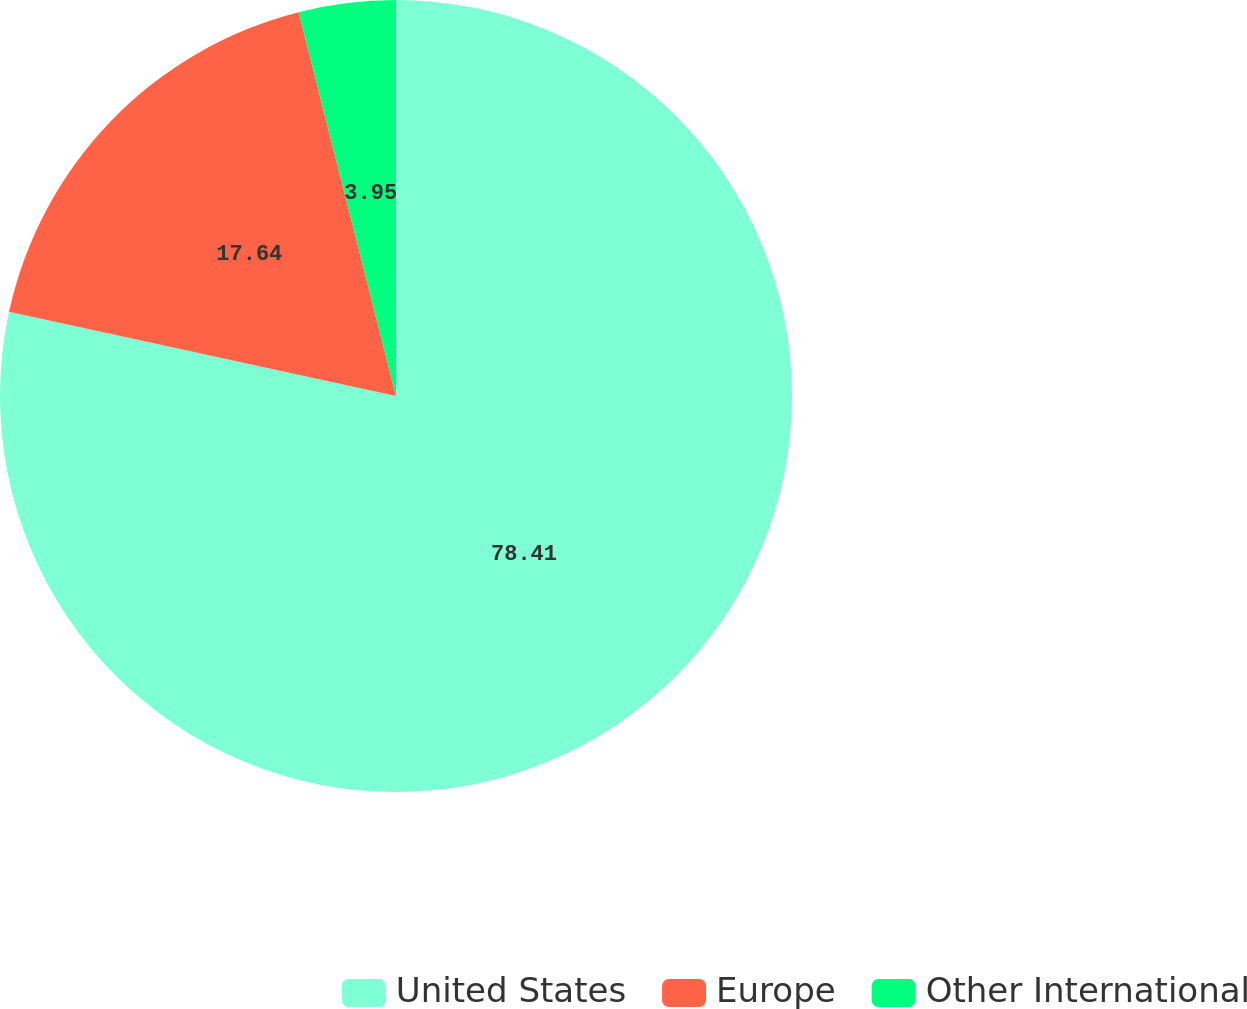Convert chart to OTSL. <chart><loc_0><loc_0><loc_500><loc_500><pie_chart><fcel>United States<fcel>Europe<fcel>Other International<nl><fcel>78.4%<fcel>17.64%<fcel>3.95%<nl></chart> 